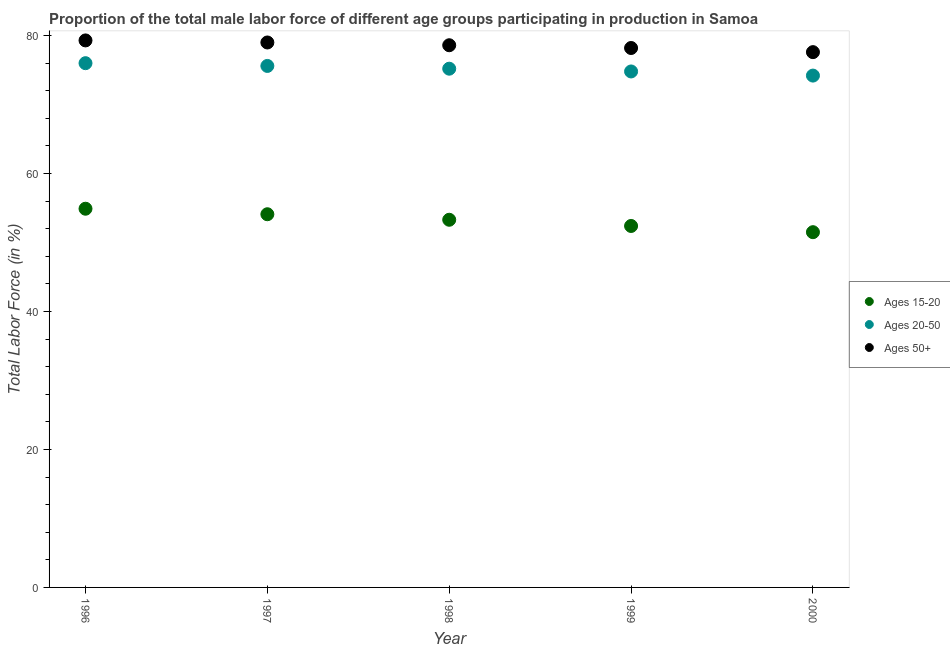How many different coloured dotlines are there?
Keep it short and to the point. 3. What is the percentage of male labor force within the age group 20-50 in 2000?
Your answer should be compact. 74.2. Across all years, what is the maximum percentage of male labor force above age 50?
Your answer should be compact. 79.3. Across all years, what is the minimum percentage of male labor force within the age group 15-20?
Your answer should be compact. 51.5. In which year was the percentage of male labor force above age 50 maximum?
Give a very brief answer. 1996. What is the total percentage of male labor force within the age group 20-50 in the graph?
Provide a succinct answer. 375.8. What is the difference between the percentage of male labor force within the age group 15-20 in 1996 and that in 1999?
Provide a succinct answer. 2.5. What is the difference between the percentage of male labor force above age 50 in 2000 and the percentage of male labor force within the age group 20-50 in 1998?
Your answer should be compact. 2.4. What is the average percentage of male labor force above age 50 per year?
Provide a succinct answer. 78.54. In the year 1996, what is the difference between the percentage of male labor force within the age group 15-20 and percentage of male labor force above age 50?
Provide a short and direct response. -24.4. What is the ratio of the percentage of male labor force within the age group 15-20 in 1996 to that in 1999?
Provide a short and direct response. 1.05. Is the percentage of male labor force above age 50 in 1998 less than that in 1999?
Keep it short and to the point. No. What is the difference between the highest and the second highest percentage of male labor force above age 50?
Provide a short and direct response. 0.3. What is the difference between the highest and the lowest percentage of male labor force within the age group 15-20?
Keep it short and to the point. 3.4. Is it the case that in every year, the sum of the percentage of male labor force within the age group 15-20 and percentage of male labor force within the age group 20-50 is greater than the percentage of male labor force above age 50?
Keep it short and to the point. Yes. Is the percentage of male labor force within the age group 20-50 strictly greater than the percentage of male labor force above age 50 over the years?
Provide a succinct answer. No. Is the percentage of male labor force above age 50 strictly less than the percentage of male labor force within the age group 15-20 over the years?
Your answer should be very brief. No. Are the values on the major ticks of Y-axis written in scientific E-notation?
Keep it short and to the point. No. Does the graph contain any zero values?
Your answer should be compact. No. Does the graph contain grids?
Provide a short and direct response. No. How many legend labels are there?
Provide a short and direct response. 3. How are the legend labels stacked?
Give a very brief answer. Vertical. What is the title of the graph?
Provide a succinct answer. Proportion of the total male labor force of different age groups participating in production in Samoa. Does "Grants" appear as one of the legend labels in the graph?
Keep it short and to the point. No. What is the label or title of the X-axis?
Your answer should be compact. Year. What is the Total Labor Force (in %) of Ages 15-20 in 1996?
Keep it short and to the point. 54.9. What is the Total Labor Force (in %) in Ages 20-50 in 1996?
Offer a terse response. 76. What is the Total Labor Force (in %) of Ages 50+ in 1996?
Provide a succinct answer. 79.3. What is the Total Labor Force (in %) in Ages 15-20 in 1997?
Keep it short and to the point. 54.1. What is the Total Labor Force (in %) in Ages 20-50 in 1997?
Your response must be concise. 75.6. What is the Total Labor Force (in %) of Ages 50+ in 1997?
Give a very brief answer. 79. What is the Total Labor Force (in %) in Ages 15-20 in 1998?
Provide a succinct answer. 53.3. What is the Total Labor Force (in %) of Ages 20-50 in 1998?
Provide a succinct answer. 75.2. What is the Total Labor Force (in %) of Ages 50+ in 1998?
Ensure brevity in your answer.  78.6. What is the Total Labor Force (in %) of Ages 15-20 in 1999?
Offer a very short reply. 52.4. What is the Total Labor Force (in %) in Ages 20-50 in 1999?
Your answer should be very brief. 74.8. What is the Total Labor Force (in %) in Ages 50+ in 1999?
Ensure brevity in your answer.  78.2. What is the Total Labor Force (in %) of Ages 15-20 in 2000?
Provide a short and direct response. 51.5. What is the Total Labor Force (in %) of Ages 20-50 in 2000?
Give a very brief answer. 74.2. What is the Total Labor Force (in %) of Ages 50+ in 2000?
Provide a succinct answer. 77.6. Across all years, what is the maximum Total Labor Force (in %) in Ages 15-20?
Keep it short and to the point. 54.9. Across all years, what is the maximum Total Labor Force (in %) in Ages 20-50?
Make the answer very short. 76. Across all years, what is the maximum Total Labor Force (in %) in Ages 50+?
Your response must be concise. 79.3. Across all years, what is the minimum Total Labor Force (in %) of Ages 15-20?
Provide a succinct answer. 51.5. Across all years, what is the minimum Total Labor Force (in %) in Ages 20-50?
Offer a terse response. 74.2. Across all years, what is the minimum Total Labor Force (in %) of Ages 50+?
Offer a terse response. 77.6. What is the total Total Labor Force (in %) of Ages 15-20 in the graph?
Provide a short and direct response. 266.2. What is the total Total Labor Force (in %) of Ages 20-50 in the graph?
Your answer should be compact. 375.8. What is the total Total Labor Force (in %) of Ages 50+ in the graph?
Offer a terse response. 392.7. What is the difference between the Total Labor Force (in %) in Ages 15-20 in 1996 and that in 1997?
Offer a terse response. 0.8. What is the difference between the Total Labor Force (in %) of Ages 50+ in 1996 and that in 1997?
Offer a very short reply. 0.3. What is the difference between the Total Labor Force (in %) of Ages 50+ in 1996 and that in 1998?
Offer a very short reply. 0.7. What is the difference between the Total Labor Force (in %) of Ages 20-50 in 1996 and that in 1999?
Keep it short and to the point. 1.2. What is the difference between the Total Labor Force (in %) in Ages 50+ in 1996 and that in 1999?
Your response must be concise. 1.1. What is the difference between the Total Labor Force (in %) of Ages 20-50 in 1996 and that in 2000?
Give a very brief answer. 1.8. What is the difference between the Total Labor Force (in %) of Ages 50+ in 1996 and that in 2000?
Provide a short and direct response. 1.7. What is the difference between the Total Labor Force (in %) of Ages 20-50 in 1997 and that in 1998?
Keep it short and to the point. 0.4. What is the difference between the Total Labor Force (in %) in Ages 50+ in 1997 and that in 1998?
Provide a succinct answer. 0.4. What is the difference between the Total Labor Force (in %) in Ages 50+ in 1997 and that in 2000?
Keep it short and to the point. 1.4. What is the difference between the Total Labor Force (in %) of Ages 15-20 in 1998 and that in 1999?
Your answer should be compact. 0.9. What is the difference between the Total Labor Force (in %) in Ages 50+ in 1998 and that in 1999?
Your response must be concise. 0.4. What is the difference between the Total Labor Force (in %) of Ages 15-20 in 1999 and that in 2000?
Give a very brief answer. 0.9. What is the difference between the Total Labor Force (in %) in Ages 15-20 in 1996 and the Total Labor Force (in %) in Ages 20-50 in 1997?
Your answer should be very brief. -20.7. What is the difference between the Total Labor Force (in %) in Ages 15-20 in 1996 and the Total Labor Force (in %) in Ages 50+ in 1997?
Ensure brevity in your answer.  -24.1. What is the difference between the Total Labor Force (in %) in Ages 20-50 in 1996 and the Total Labor Force (in %) in Ages 50+ in 1997?
Give a very brief answer. -3. What is the difference between the Total Labor Force (in %) in Ages 15-20 in 1996 and the Total Labor Force (in %) in Ages 20-50 in 1998?
Your response must be concise. -20.3. What is the difference between the Total Labor Force (in %) of Ages 15-20 in 1996 and the Total Labor Force (in %) of Ages 50+ in 1998?
Offer a terse response. -23.7. What is the difference between the Total Labor Force (in %) of Ages 15-20 in 1996 and the Total Labor Force (in %) of Ages 20-50 in 1999?
Provide a succinct answer. -19.9. What is the difference between the Total Labor Force (in %) of Ages 15-20 in 1996 and the Total Labor Force (in %) of Ages 50+ in 1999?
Your response must be concise. -23.3. What is the difference between the Total Labor Force (in %) in Ages 20-50 in 1996 and the Total Labor Force (in %) in Ages 50+ in 1999?
Provide a succinct answer. -2.2. What is the difference between the Total Labor Force (in %) in Ages 15-20 in 1996 and the Total Labor Force (in %) in Ages 20-50 in 2000?
Make the answer very short. -19.3. What is the difference between the Total Labor Force (in %) of Ages 15-20 in 1996 and the Total Labor Force (in %) of Ages 50+ in 2000?
Ensure brevity in your answer.  -22.7. What is the difference between the Total Labor Force (in %) in Ages 20-50 in 1996 and the Total Labor Force (in %) in Ages 50+ in 2000?
Your response must be concise. -1.6. What is the difference between the Total Labor Force (in %) of Ages 15-20 in 1997 and the Total Labor Force (in %) of Ages 20-50 in 1998?
Ensure brevity in your answer.  -21.1. What is the difference between the Total Labor Force (in %) in Ages 15-20 in 1997 and the Total Labor Force (in %) in Ages 50+ in 1998?
Provide a succinct answer. -24.5. What is the difference between the Total Labor Force (in %) in Ages 20-50 in 1997 and the Total Labor Force (in %) in Ages 50+ in 1998?
Make the answer very short. -3. What is the difference between the Total Labor Force (in %) of Ages 15-20 in 1997 and the Total Labor Force (in %) of Ages 20-50 in 1999?
Ensure brevity in your answer.  -20.7. What is the difference between the Total Labor Force (in %) in Ages 15-20 in 1997 and the Total Labor Force (in %) in Ages 50+ in 1999?
Your answer should be very brief. -24.1. What is the difference between the Total Labor Force (in %) of Ages 20-50 in 1997 and the Total Labor Force (in %) of Ages 50+ in 1999?
Provide a succinct answer. -2.6. What is the difference between the Total Labor Force (in %) in Ages 15-20 in 1997 and the Total Labor Force (in %) in Ages 20-50 in 2000?
Make the answer very short. -20.1. What is the difference between the Total Labor Force (in %) in Ages 15-20 in 1997 and the Total Labor Force (in %) in Ages 50+ in 2000?
Offer a very short reply. -23.5. What is the difference between the Total Labor Force (in %) of Ages 20-50 in 1997 and the Total Labor Force (in %) of Ages 50+ in 2000?
Offer a very short reply. -2. What is the difference between the Total Labor Force (in %) of Ages 15-20 in 1998 and the Total Labor Force (in %) of Ages 20-50 in 1999?
Offer a terse response. -21.5. What is the difference between the Total Labor Force (in %) of Ages 15-20 in 1998 and the Total Labor Force (in %) of Ages 50+ in 1999?
Your answer should be very brief. -24.9. What is the difference between the Total Labor Force (in %) in Ages 15-20 in 1998 and the Total Labor Force (in %) in Ages 20-50 in 2000?
Your response must be concise. -20.9. What is the difference between the Total Labor Force (in %) in Ages 15-20 in 1998 and the Total Labor Force (in %) in Ages 50+ in 2000?
Provide a succinct answer. -24.3. What is the difference between the Total Labor Force (in %) of Ages 20-50 in 1998 and the Total Labor Force (in %) of Ages 50+ in 2000?
Offer a very short reply. -2.4. What is the difference between the Total Labor Force (in %) of Ages 15-20 in 1999 and the Total Labor Force (in %) of Ages 20-50 in 2000?
Your answer should be very brief. -21.8. What is the difference between the Total Labor Force (in %) of Ages 15-20 in 1999 and the Total Labor Force (in %) of Ages 50+ in 2000?
Keep it short and to the point. -25.2. What is the difference between the Total Labor Force (in %) of Ages 20-50 in 1999 and the Total Labor Force (in %) of Ages 50+ in 2000?
Give a very brief answer. -2.8. What is the average Total Labor Force (in %) in Ages 15-20 per year?
Keep it short and to the point. 53.24. What is the average Total Labor Force (in %) in Ages 20-50 per year?
Keep it short and to the point. 75.16. What is the average Total Labor Force (in %) of Ages 50+ per year?
Your answer should be compact. 78.54. In the year 1996, what is the difference between the Total Labor Force (in %) in Ages 15-20 and Total Labor Force (in %) in Ages 20-50?
Ensure brevity in your answer.  -21.1. In the year 1996, what is the difference between the Total Labor Force (in %) of Ages 15-20 and Total Labor Force (in %) of Ages 50+?
Keep it short and to the point. -24.4. In the year 1996, what is the difference between the Total Labor Force (in %) of Ages 20-50 and Total Labor Force (in %) of Ages 50+?
Your response must be concise. -3.3. In the year 1997, what is the difference between the Total Labor Force (in %) of Ages 15-20 and Total Labor Force (in %) of Ages 20-50?
Ensure brevity in your answer.  -21.5. In the year 1997, what is the difference between the Total Labor Force (in %) in Ages 15-20 and Total Labor Force (in %) in Ages 50+?
Your answer should be very brief. -24.9. In the year 1997, what is the difference between the Total Labor Force (in %) in Ages 20-50 and Total Labor Force (in %) in Ages 50+?
Your answer should be compact. -3.4. In the year 1998, what is the difference between the Total Labor Force (in %) in Ages 15-20 and Total Labor Force (in %) in Ages 20-50?
Ensure brevity in your answer.  -21.9. In the year 1998, what is the difference between the Total Labor Force (in %) of Ages 15-20 and Total Labor Force (in %) of Ages 50+?
Provide a succinct answer. -25.3. In the year 1998, what is the difference between the Total Labor Force (in %) in Ages 20-50 and Total Labor Force (in %) in Ages 50+?
Your response must be concise. -3.4. In the year 1999, what is the difference between the Total Labor Force (in %) in Ages 15-20 and Total Labor Force (in %) in Ages 20-50?
Provide a short and direct response. -22.4. In the year 1999, what is the difference between the Total Labor Force (in %) of Ages 15-20 and Total Labor Force (in %) of Ages 50+?
Your answer should be very brief. -25.8. In the year 2000, what is the difference between the Total Labor Force (in %) of Ages 15-20 and Total Labor Force (in %) of Ages 20-50?
Offer a very short reply. -22.7. In the year 2000, what is the difference between the Total Labor Force (in %) in Ages 15-20 and Total Labor Force (in %) in Ages 50+?
Offer a very short reply. -26.1. What is the ratio of the Total Labor Force (in %) in Ages 15-20 in 1996 to that in 1997?
Your answer should be compact. 1.01. What is the ratio of the Total Labor Force (in %) in Ages 20-50 in 1996 to that in 1997?
Offer a terse response. 1.01. What is the ratio of the Total Labor Force (in %) of Ages 50+ in 1996 to that in 1997?
Offer a very short reply. 1. What is the ratio of the Total Labor Force (in %) in Ages 20-50 in 1996 to that in 1998?
Your answer should be compact. 1.01. What is the ratio of the Total Labor Force (in %) of Ages 50+ in 1996 to that in 1998?
Offer a very short reply. 1.01. What is the ratio of the Total Labor Force (in %) in Ages 15-20 in 1996 to that in 1999?
Give a very brief answer. 1.05. What is the ratio of the Total Labor Force (in %) of Ages 20-50 in 1996 to that in 1999?
Offer a very short reply. 1.02. What is the ratio of the Total Labor Force (in %) in Ages 50+ in 1996 to that in 1999?
Ensure brevity in your answer.  1.01. What is the ratio of the Total Labor Force (in %) in Ages 15-20 in 1996 to that in 2000?
Ensure brevity in your answer.  1.07. What is the ratio of the Total Labor Force (in %) in Ages 20-50 in 1996 to that in 2000?
Ensure brevity in your answer.  1.02. What is the ratio of the Total Labor Force (in %) of Ages 50+ in 1996 to that in 2000?
Provide a succinct answer. 1.02. What is the ratio of the Total Labor Force (in %) in Ages 15-20 in 1997 to that in 1998?
Your response must be concise. 1.01. What is the ratio of the Total Labor Force (in %) of Ages 20-50 in 1997 to that in 1998?
Provide a short and direct response. 1.01. What is the ratio of the Total Labor Force (in %) in Ages 15-20 in 1997 to that in 1999?
Keep it short and to the point. 1.03. What is the ratio of the Total Labor Force (in %) of Ages 20-50 in 1997 to that in 1999?
Ensure brevity in your answer.  1.01. What is the ratio of the Total Labor Force (in %) in Ages 50+ in 1997 to that in 1999?
Offer a very short reply. 1.01. What is the ratio of the Total Labor Force (in %) in Ages 15-20 in 1997 to that in 2000?
Keep it short and to the point. 1.05. What is the ratio of the Total Labor Force (in %) in Ages 20-50 in 1997 to that in 2000?
Offer a very short reply. 1.02. What is the ratio of the Total Labor Force (in %) in Ages 50+ in 1997 to that in 2000?
Make the answer very short. 1.02. What is the ratio of the Total Labor Force (in %) in Ages 15-20 in 1998 to that in 1999?
Provide a short and direct response. 1.02. What is the ratio of the Total Labor Force (in %) in Ages 50+ in 1998 to that in 1999?
Offer a terse response. 1.01. What is the ratio of the Total Labor Force (in %) in Ages 15-20 in 1998 to that in 2000?
Make the answer very short. 1.03. What is the ratio of the Total Labor Force (in %) in Ages 20-50 in 1998 to that in 2000?
Your response must be concise. 1.01. What is the ratio of the Total Labor Force (in %) in Ages 50+ in 1998 to that in 2000?
Provide a short and direct response. 1.01. What is the ratio of the Total Labor Force (in %) of Ages 15-20 in 1999 to that in 2000?
Your answer should be compact. 1.02. What is the ratio of the Total Labor Force (in %) of Ages 20-50 in 1999 to that in 2000?
Ensure brevity in your answer.  1.01. What is the ratio of the Total Labor Force (in %) of Ages 50+ in 1999 to that in 2000?
Provide a short and direct response. 1.01. What is the difference between the highest and the second highest Total Labor Force (in %) of Ages 50+?
Ensure brevity in your answer.  0.3. What is the difference between the highest and the lowest Total Labor Force (in %) of Ages 20-50?
Provide a succinct answer. 1.8. 